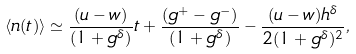<formula> <loc_0><loc_0><loc_500><loc_500>\langle n ( t ) \rangle \simeq \frac { ( u - w ) } { ( 1 + g ^ { \delta } ) } t + \frac { ( g ^ { + } - g ^ { - } ) } { ( 1 + g ^ { \delta } ) } - \frac { ( u - w ) h ^ { \delta } } { 2 ( 1 + g ^ { \delta } ) ^ { 2 } } ,</formula> 